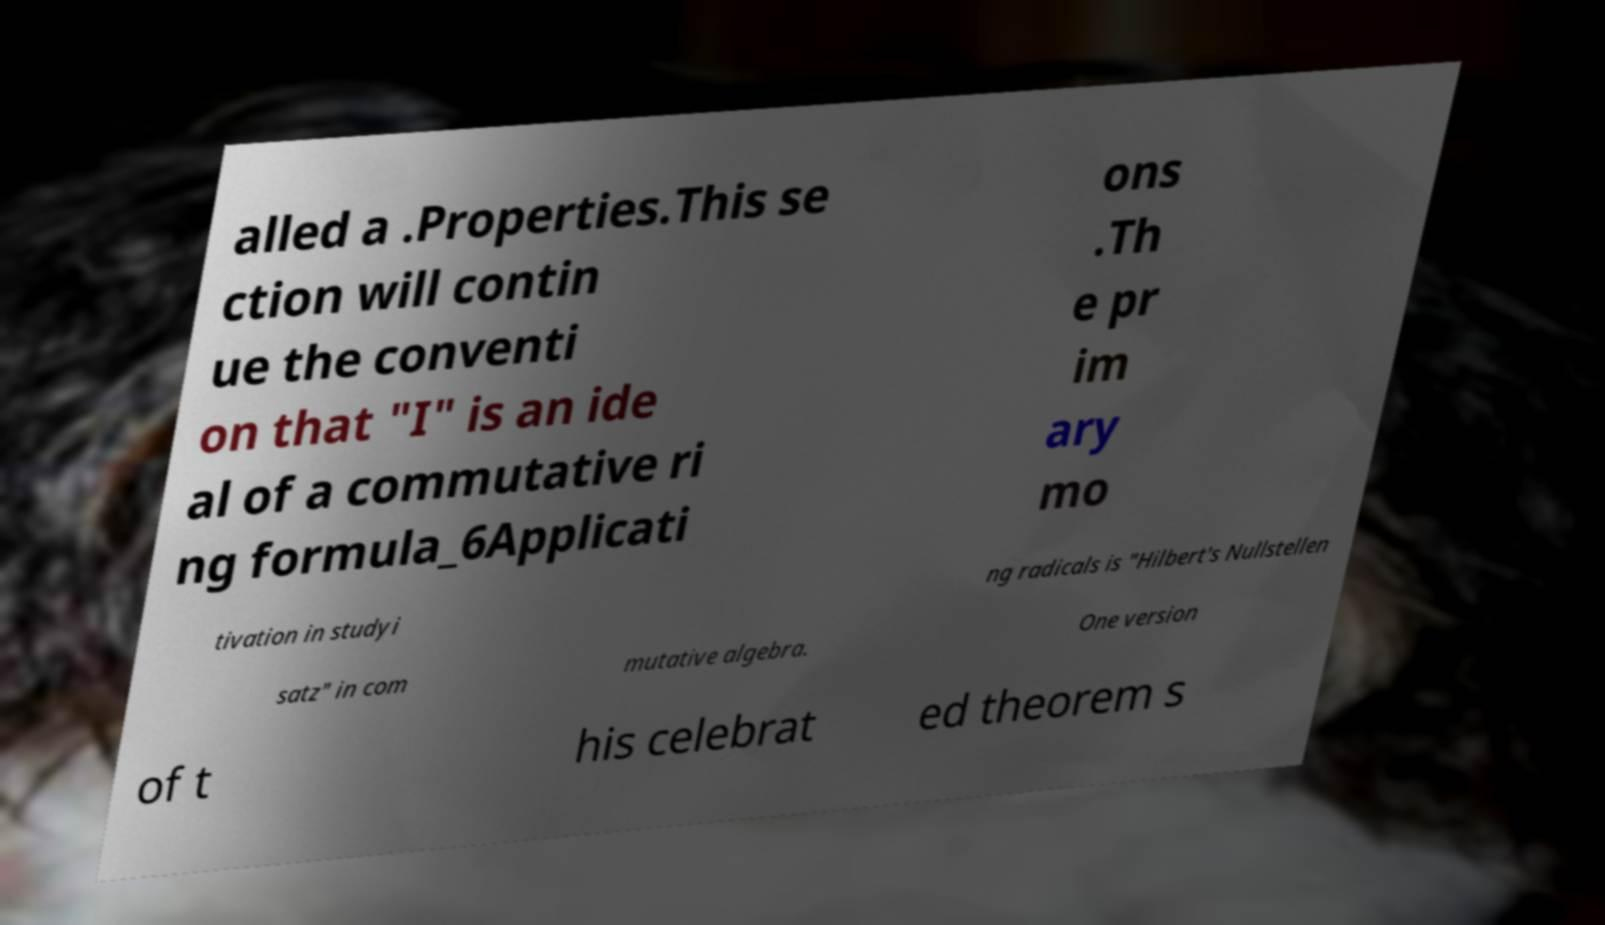Can you read and provide the text displayed in the image?This photo seems to have some interesting text. Can you extract and type it out for me? alled a .Properties.This se ction will contin ue the conventi on that "I" is an ide al of a commutative ri ng formula_6Applicati ons .Th e pr im ary mo tivation in studyi ng radicals is "Hilbert's Nullstellen satz" in com mutative algebra. One version of t his celebrat ed theorem s 